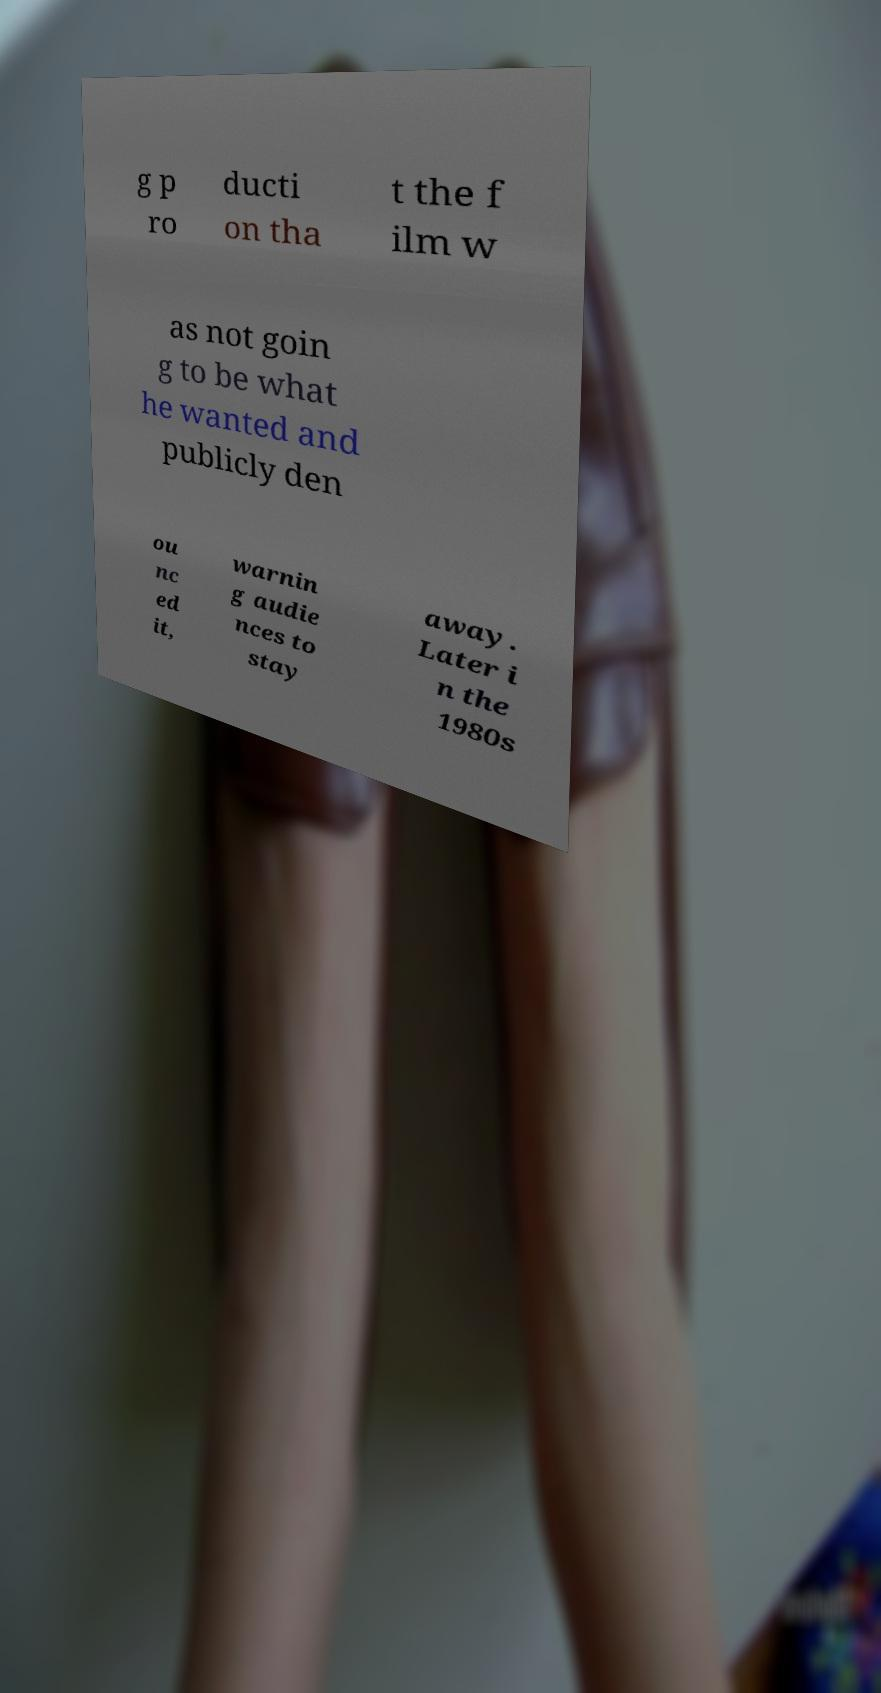Please read and relay the text visible in this image. What does it say? g p ro ducti on tha t the f ilm w as not goin g to be what he wanted and publicly den ou nc ed it, warnin g audie nces to stay away. Later i n the 1980s 